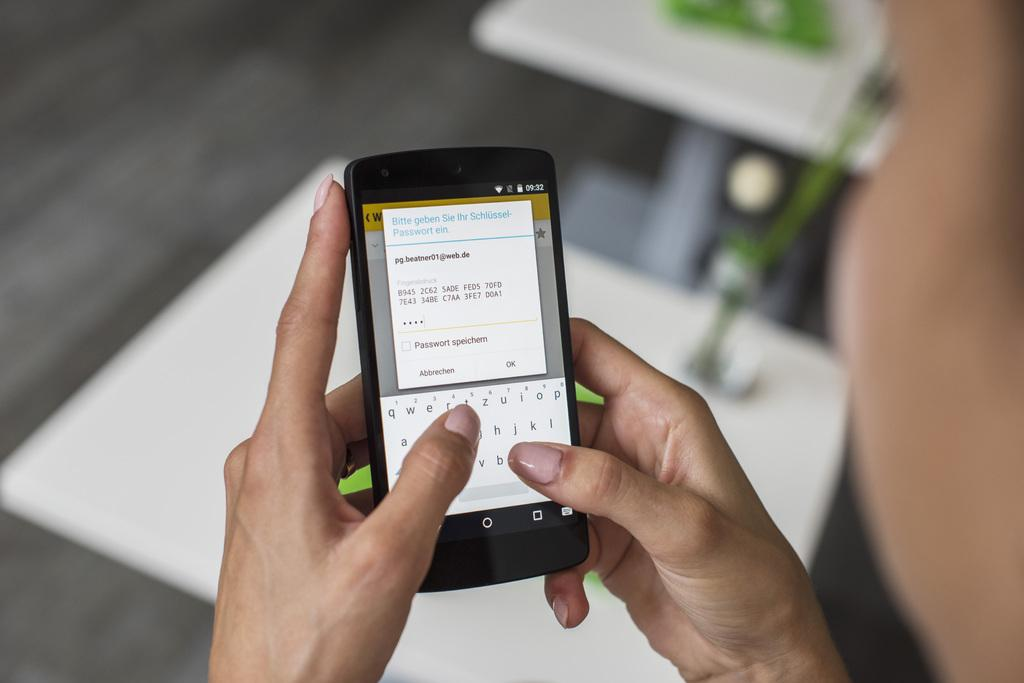What is the main subject of the image? There is a person in the image. What is the person holding in the image? The person is holding a mobile. What can be seen on the mobile? There is text visible on the mobile. Can you describe the background of the image? There are objects in the background of the image. What type of process is the monkey performing in the image? There is no monkey present in the image, so no process can be observed. 